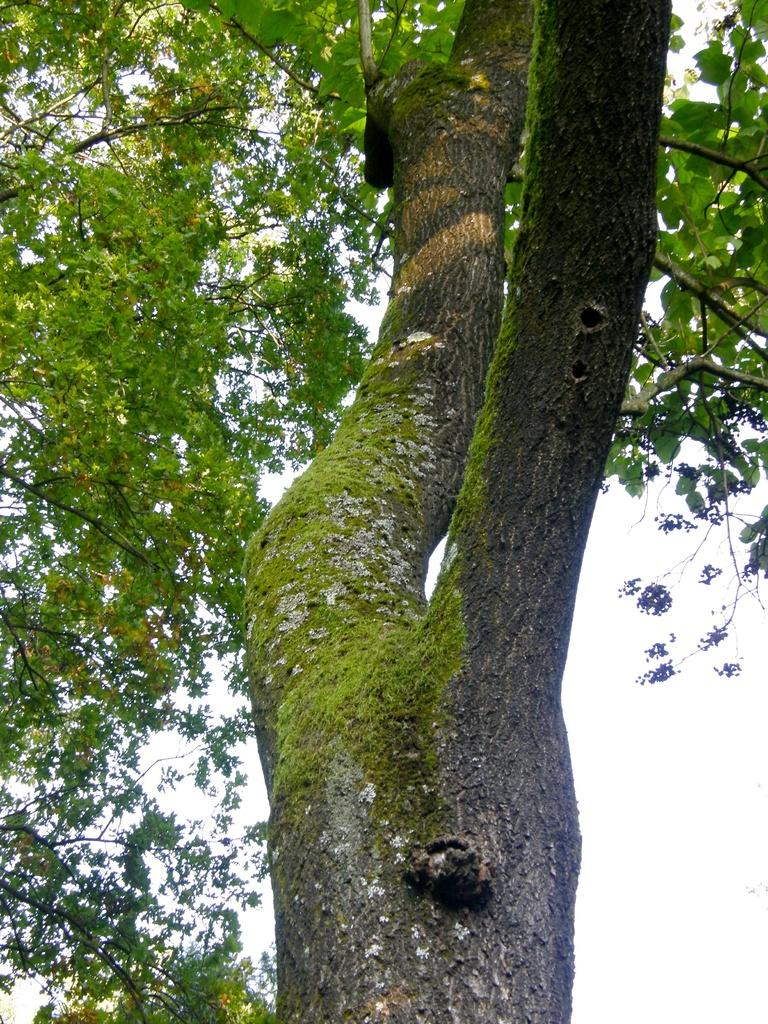What is the main subject in the center of the image? There is a tree in the center of the image. What can be seen in the background of the image? There is sky visible in the background of the image. What is present in the sky? Clouds are present in the sky. What type of plastic is used to create the observation deck in the image? There is no observation deck present in the image, so it is not possible to determine what type of plastic might be used. 